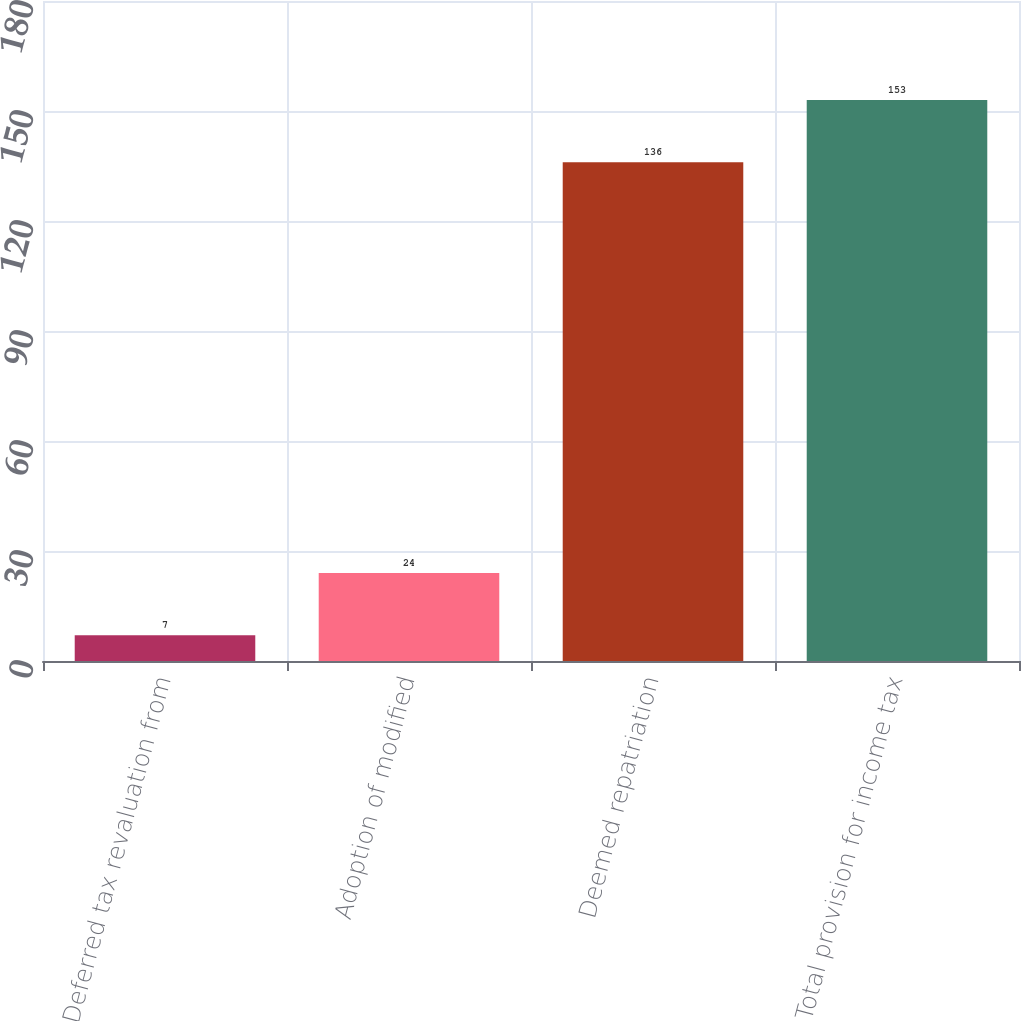Convert chart to OTSL. <chart><loc_0><loc_0><loc_500><loc_500><bar_chart><fcel>Deferred tax revaluation from<fcel>Adoption of modified<fcel>Deemed repatriation<fcel>Total provision for income tax<nl><fcel>7<fcel>24<fcel>136<fcel>153<nl></chart> 